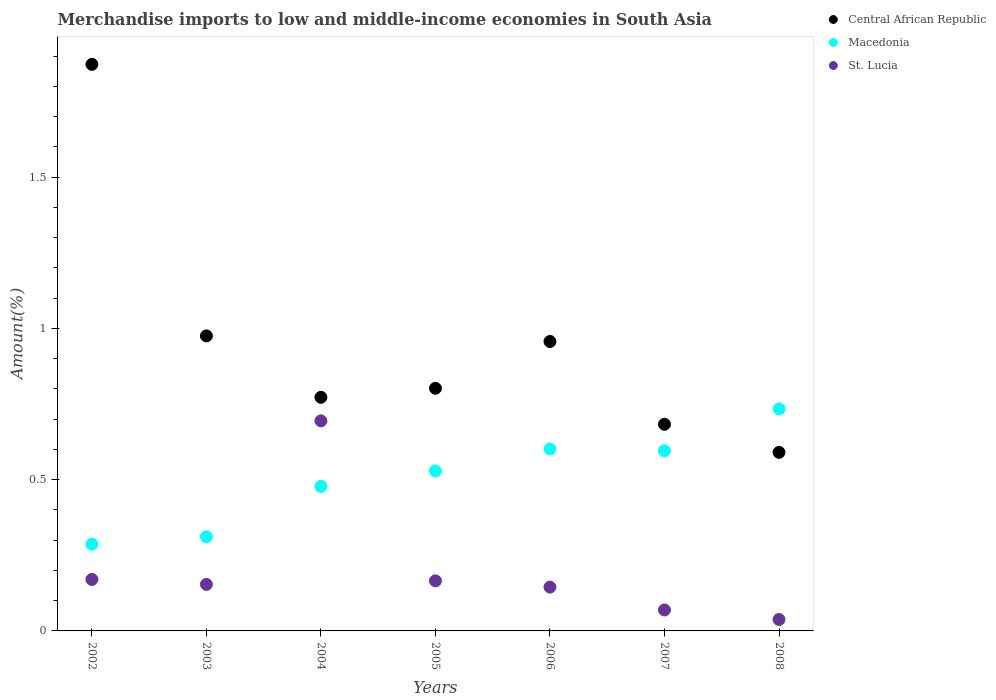Is the number of dotlines equal to the number of legend labels?
Provide a short and direct response. Yes. What is the percentage of amount earned from merchandise imports in St. Lucia in 2007?
Provide a succinct answer. 0.07. Across all years, what is the maximum percentage of amount earned from merchandise imports in St. Lucia?
Give a very brief answer. 0.69. Across all years, what is the minimum percentage of amount earned from merchandise imports in St. Lucia?
Your answer should be compact. 0.04. What is the total percentage of amount earned from merchandise imports in Macedonia in the graph?
Give a very brief answer. 3.54. What is the difference between the percentage of amount earned from merchandise imports in Central African Republic in 2004 and that in 2008?
Your answer should be very brief. 0.18. What is the difference between the percentage of amount earned from merchandise imports in St. Lucia in 2002 and the percentage of amount earned from merchandise imports in Macedonia in 2007?
Keep it short and to the point. -0.43. What is the average percentage of amount earned from merchandise imports in Central African Republic per year?
Make the answer very short. 0.95. In the year 2005, what is the difference between the percentage of amount earned from merchandise imports in St. Lucia and percentage of amount earned from merchandise imports in Central African Republic?
Your answer should be compact. -0.64. In how many years, is the percentage of amount earned from merchandise imports in Macedonia greater than 1.1 %?
Give a very brief answer. 0. What is the ratio of the percentage of amount earned from merchandise imports in Macedonia in 2004 to that in 2007?
Offer a very short reply. 0.8. Is the difference between the percentage of amount earned from merchandise imports in St. Lucia in 2007 and 2008 greater than the difference between the percentage of amount earned from merchandise imports in Central African Republic in 2007 and 2008?
Your response must be concise. No. What is the difference between the highest and the second highest percentage of amount earned from merchandise imports in Central African Republic?
Provide a succinct answer. 0.9. What is the difference between the highest and the lowest percentage of amount earned from merchandise imports in St. Lucia?
Your answer should be compact. 0.66. Does the percentage of amount earned from merchandise imports in St. Lucia monotonically increase over the years?
Your answer should be very brief. No. Is the percentage of amount earned from merchandise imports in Central African Republic strictly greater than the percentage of amount earned from merchandise imports in St. Lucia over the years?
Offer a terse response. Yes. What is the difference between two consecutive major ticks on the Y-axis?
Ensure brevity in your answer.  0.5. Does the graph contain any zero values?
Keep it short and to the point. No. Does the graph contain grids?
Make the answer very short. No. What is the title of the graph?
Ensure brevity in your answer.  Merchandise imports to low and middle-income economies in South Asia. Does "Kuwait" appear as one of the legend labels in the graph?
Make the answer very short. No. What is the label or title of the X-axis?
Give a very brief answer. Years. What is the label or title of the Y-axis?
Offer a very short reply. Amount(%). What is the Amount(%) of Central African Republic in 2002?
Offer a terse response. 1.87. What is the Amount(%) of Macedonia in 2002?
Make the answer very short. 0.29. What is the Amount(%) in St. Lucia in 2002?
Offer a very short reply. 0.17. What is the Amount(%) of Central African Republic in 2003?
Keep it short and to the point. 0.98. What is the Amount(%) in Macedonia in 2003?
Give a very brief answer. 0.31. What is the Amount(%) in St. Lucia in 2003?
Ensure brevity in your answer.  0.15. What is the Amount(%) in Central African Republic in 2004?
Your answer should be compact. 0.77. What is the Amount(%) of Macedonia in 2004?
Keep it short and to the point. 0.48. What is the Amount(%) in St. Lucia in 2004?
Provide a short and direct response. 0.69. What is the Amount(%) of Central African Republic in 2005?
Your answer should be very brief. 0.8. What is the Amount(%) in Macedonia in 2005?
Offer a terse response. 0.53. What is the Amount(%) in St. Lucia in 2005?
Ensure brevity in your answer.  0.17. What is the Amount(%) in Central African Republic in 2006?
Give a very brief answer. 0.96. What is the Amount(%) of Macedonia in 2006?
Give a very brief answer. 0.6. What is the Amount(%) of St. Lucia in 2006?
Give a very brief answer. 0.14. What is the Amount(%) in Central African Republic in 2007?
Ensure brevity in your answer.  0.68. What is the Amount(%) of Macedonia in 2007?
Provide a succinct answer. 0.6. What is the Amount(%) in St. Lucia in 2007?
Offer a terse response. 0.07. What is the Amount(%) of Central African Republic in 2008?
Provide a succinct answer. 0.59. What is the Amount(%) of Macedonia in 2008?
Provide a short and direct response. 0.73. What is the Amount(%) in St. Lucia in 2008?
Make the answer very short. 0.04. Across all years, what is the maximum Amount(%) in Central African Republic?
Keep it short and to the point. 1.87. Across all years, what is the maximum Amount(%) in Macedonia?
Offer a terse response. 0.73. Across all years, what is the maximum Amount(%) in St. Lucia?
Provide a short and direct response. 0.69. Across all years, what is the minimum Amount(%) in Central African Republic?
Provide a succinct answer. 0.59. Across all years, what is the minimum Amount(%) in Macedonia?
Give a very brief answer. 0.29. Across all years, what is the minimum Amount(%) of St. Lucia?
Give a very brief answer. 0.04. What is the total Amount(%) of Central African Republic in the graph?
Ensure brevity in your answer.  6.65. What is the total Amount(%) of Macedonia in the graph?
Your answer should be very brief. 3.54. What is the total Amount(%) of St. Lucia in the graph?
Offer a very short reply. 1.44. What is the difference between the Amount(%) in Central African Republic in 2002 and that in 2003?
Keep it short and to the point. 0.9. What is the difference between the Amount(%) of Macedonia in 2002 and that in 2003?
Ensure brevity in your answer.  -0.02. What is the difference between the Amount(%) of St. Lucia in 2002 and that in 2003?
Your answer should be compact. 0.02. What is the difference between the Amount(%) of Central African Republic in 2002 and that in 2004?
Your answer should be very brief. 1.1. What is the difference between the Amount(%) in Macedonia in 2002 and that in 2004?
Give a very brief answer. -0.19. What is the difference between the Amount(%) in St. Lucia in 2002 and that in 2004?
Your answer should be very brief. -0.52. What is the difference between the Amount(%) of Central African Republic in 2002 and that in 2005?
Make the answer very short. 1.07. What is the difference between the Amount(%) of Macedonia in 2002 and that in 2005?
Ensure brevity in your answer.  -0.24. What is the difference between the Amount(%) in St. Lucia in 2002 and that in 2005?
Give a very brief answer. 0. What is the difference between the Amount(%) in Central African Republic in 2002 and that in 2006?
Provide a succinct answer. 0.92. What is the difference between the Amount(%) of Macedonia in 2002 and that in 2006?
Make the answer very short. -0.31. What is the difference between the Amount(%) of St. Lucia in 2002 and that in 2006?
Your response must be concise. 0.03. What is the difference between the Amount(%) of Central African Republic in 2002 and that in 2007?
Your answer should be compact. 1.19. What is the difference between the Amount(%) of Macedonia in 2002 and that in 2007?
Give a very brief answer. -0.31. What is the difference between the Amount(%) of St. Lucia in 2002 and that in 2007?
Keep it short and to the point. 0.1. What is the difference between the Amount(%) of Central African Republic in 2002 and that in 2008?
Provide a short and direct response. 1.28. What is the difference between the Amount(%) of Macedonia in 2002 and that in 2008?
Your answer should be compact. -0.45. What is the difference between the Amount(%) in St. Lucia in 2002 and that in 2008?
Your answer should be very brief. 0.13. What is the difference between the Amount(%) of Central African Republic in 2003 and that in 2004?
Keep it short and to the point. 0.2. What is the difference between the Amount(%) in Macedonia in 2003 and that in 2004?
Provide a succinct answer. -0.17. What is the difference between the Amount(%) of St. Lucia in 2003 and that in 2004?
Keep it short and to the point. -0.54. What is the difference between the Amount(%) in Central African Republic in 2003 and that in 2005?
Your answer should be very brief. 0.17. What is the difference between the Amount(%) of Macedonia in 2003 and that in 2005?
Provide a succinct answer. -0.22. What is the difference between the Amount(%) in St. Lucia in 2003 and that in 2005?
Make the answer very short. -0.01. What is the difference between the Amount(%) of Central African Republic in 2003 and that in 2006?
Give a very brief answer. 0.02. What is the difference between the Amount(%) in Macedonia in 2003 and that in 2006?
Offer a terse response. -0.29. What is the difference between the Amount(%) in St. Lucia in 2003 and that in 2006?
Your answer should be very brief. 0.01. What is the difference between the Amount(%) of Central African Republic in 2003 and that in 2007?
Your answer should be compact. 0.29. What is the difference between the Amount(%) in Macedonia in 2003 and that in 2007?
Keep it short and to the point. -0.28. What is the difference between the Amount(%) of St. Lucia in 2003 and that in 2007?
Offer a terse response. 0.08. What is the difference between the Amount(%) of Central African Republic in 2003 and that in 2008?
Provide a short and direct response. 0.39. What is the difference between the Amount(%) in Macedonia in 2003 and that in 2008?
Keep it short and to the point. -0.42. What is the difference between the Amount(%) of St. Lucia in 2003 and that in 2008?
Provide a short and direct response. 0.12. What is the difference between the Amount(%) of Central African Republic in 2004 and that in 2005?
Keep it short and to the point. -0.03. What is the difference between the Amount(%) of Macedonia in 2004 and that in 2005?
Offer a very short reply. -0.05. What is the difference between the Amount(%) of St. Lucia in 2004 and that in 2005?
Offer a terse response. 0.53. What is the difference between the Amount(%) in Central African Republic in 2004 and that in 2006?
Your answer should be very brief. -0.18. What is the difference between the Amount(%) in Macedonia in 2004 and that in 2006?
Your response must be concise. -0.12. What is the difference between the Amount(%) in St. Lucia in 2004 and that in 2006?
Keep it short and to the point. 0.55. What is the difference between the Amount(%) of Central African Republic in 2004 and that in 2007?
Give a very brief answer. 0.09. What is the difference between the Amount(%) of Macedonia in 2004 and that in 2007?
Offer a terse response. -0.12. What is the difference between the Amount(%) of St. Lucia in 2004 and that in 2007?
Your response must be concise. 0.63. What is the difference between the Amount(%) of Central African Republic in 2004 and that in 2008?
Provide a short and direct response. 0.18. What is the difference between the Amount(%) of Macedonia in 2004 and that in 2008?
Offer a very short reply. -0.26. What is the difference between the Amount(%) in St. Lucia in 2004 and that in 2008?
Your answer should be very brief. 0.66. What is the difference between the Amount(%) in Central African Republic in 2005 and that in 2006?
Provide a succinct answer. -0.15. What is the difference between the Amount(%) in Macedonia in 2005 and that in 2006?
Your answer should be very brief. -0.07. What is the difference between the Amount(%) in St. Lucia in 2005 and that in 2006?
Your response must be concise. 0.02. What is the difference between the Amount(%) in Central African Republic in 2005 and that in 2007?
Make the answer very short. 0.12. What is the difference between the Amount(%) of Macedonia in 2005 and that in 2007?
Make the answer very short. -0.07. What is the difference between the Amount(%) of St. Lucia in 2005 and that in 2007?
Provide a short and direct response. 0.1. What is the difference between the Amount(%) of Central African Republic in 2005 and that in 2008?
Offer a terse response. 0.21. What is the difference between the Amount(%) in Macedonia in 2005 and that in 2008?
Your answer should be compact. -0.21. What is the difference between the Amount(%) of St. Lucia in 2005 and that in 2008?
Ensure brevity in your answer.  0.13. What is the difference between the Amount(%) of Central African Republic in 2006 and that in 2007?
Give a very brief answer. 0.27. What is the difference between the Amount(%) in Macedonia in 2006 and that in 2007?
Keep it short and to the point. 0.01. What is the difference between the Amount(%) in St. Lucia in 2006 and that in 2007?
Give a very brief answer. 0.08. What is the difference between the Amount(%) of Central African Republic in 2006 and that in 2008?
Keep it short and to the point. 0.37. What is the difference between the Amount(%) in Macedonia in 2006 and that in 2008?
Provide a succinct answer. -0.13. What is the difference between the Amount(%) of St. Lucia in 2006 and that in 2008?
Your answer should be very brief. 0.11. What is the difference between the Amount(%) of Central African Republic in 2007 and that in 2008?
Offer a very short reply. 0.09. What is the difference between the Amount(%) in Macedonia in 2007 and that in 2008?
Make the answer very short. -0.14. What is the difference between the Amount(%) of St. Lucia in 2007 and that in 2008?
Give a very brief answer. 0.03. What is the difference between the Amount(%) of Central African Republic in 2002 and the Amount(%) of Macedonia in 2003?
Ensure brevity in your answer.  1.56. What is the difference between the Amount(%) of Central African Republic in 2002 and the Amount(%) of St. Lucia in 2003?
Offer a very short reply. 1.72. What is the difference between the Amount(%) of Macedonia in 2002 and the Amount(%) of St. Lucia in 2003?
Your response must be concise. 0.13. What is the difference between the Amount(%) of Central African Republic in 2002 and the Amount(%) of Macedonia in 2004?
Ensure brevity in your answer.  1.4. What is the difference between the Amount(%) in Central African Republic in 2002 and the Amount(%) in St. Lucia in 2004?
Offer a very short reply. 1.18. What is the difference between the Amount(%) in Macedonia in 2002 and the Amount(%) in St. Lucia in 2004?
Provide a short and direct response. -0.41. What is the difference between the Amount(%) of Central African Republic in 2002 and the Amount(%) of Macedonia in 2005?
Offer a terse response. 1.34. What is the difference between the Amount(%) of Central African Republic in 2002 and the Amount(%) of St. Lucia in 2005?
Offer a very short reply. 1.71. What is the difference between the Amount(%) of Macedonia in 2002 and the Amount(%) of St. Lucia in 2005?
Offer a terse response. 0.12. What is the difference between the Amount(%) of Central African Republic in 2002 and the Amount(%) of Macedonia in 2006?
Provide a succinct answer. 1.27. What is the difference between the Amount(%) in Central African Republic in 2002 and the Amount(%) in St. Lucia in 2006?
Your answer should be very brief. 1.73. What is the difference between the Amount(%) in Macedonia in 2002 and the Amount(%) in St. Lucia in 2006?
Provide a short and direct response. 0.14. What is the difference between the Amount(%) in Central African Republic in 2002 and the Amount(%) in Macedonia in 2007?
Offer a very short reply. 1.28. What is the difference between the Amount(%) of Central African Republic in 2002 and the Amount(%) of St. Lucia in 2007?
Provide a succinct answer. 1.8. What is the difference between the Amount(%) in Macedonia in 2002 and the Amount(%) in St. Lucia in 2007?
Give a very brief answer. 0.22. What is the difference between the Amount(%) in Central African Republic in 2002 and the Amount(%) in Macedonia in 2008?
Offer a very short reply. 1.14. What is the difference between the Amount(%) of Central African Republic in 2002 and the Amount(%) of St. Lucia in 2008?
Ensure brevity in your answer.  1.84. What is the difference between the Amount(%) in Macedonia in 2002 and the Amount(%) in St. Lucia in 2008?
Give a very brief answer. 0.25. What is the difference between the Amount(%) of Central African Republic in 2003 and the Amount(%) of Macedonia in 2004?
Your answer should be compact. 0.5. What is the difference between the Amount(%) of Central African Republic in 2003 and the Amount(%) of St. Lucia in 2004?
Keep it short and to the point. 0.28. What is the difference between the Amount(%) in Macedonia in 2003 and the Amount(%) in St. Lucia in 2004?
Keep it short and to the point. -0.38. What is the difference between the Amount(%) in Central African Republic in 2003 and the Amount(%) in Macedonia in 2005?
Provide a short and direct response. 0.45. What is the difference between the Amount(%) in Central African Republic in 2003 and the Amount(%) in St. Lucia in 2005?
Make the answer very short. 0.81. What is the difference between the Amount(%) in Macedonia in 2003 and the Amount(%) in St. Lucia in 2005?
Provide a succinct answer. 0.15. What is the difference between the Amount(%) of Central African Republic in 2003 and the Amount(%) of Macedonia in 2006?
Give a very brief answer. 0.37. What is the difference between the Amount(%) of Central African Republic in 2003 and the Amount(%) of St. Lucia in 2006?
Make the answer very short. 0.83. What is the difference between the Amount(%) in Macedonia in 2003 and the Amount(%) in St. Lucia in 2006?
Your response must be concise. 0.17. What is the difference between the Amount(%) in Central African Republic in 2003 and the Amount(%) in Macedonia in 2007?
Provide a succinct answer. 0.38. What is the difference between the Amount(%) in Central African Republic in 2003 and the Amount(%) in St. Lucia in 2007?
Your response must be concise. 0.91. What is the difference between the Amount(%) of Macedonia in 2003 and the Amount(%) of St. Lucia in 2007?
Offer a terse response. 0.24. What is the difference between the Amount(%) of Central African Republic in 2003 and the Amount(%) of Macedonia in 2008?
Make the answer very short. 0.24. What is the difference between the Amount(%) of Central African Republic in 2003 and the Amount(%) of St. Lucia in 2008?
Offer a very short reply. 0.94. What is the difference between the Amount(%) in Macedonia in 2003 and the Amount(%) in St. Lucia in 2008?
Give a very brief answer. 0.27. What is the difference between the Amount(%) of Central African Republic in 2004 and the Amount(%) of Macedonia in 2005?
Provide a succinct answer. 0.24. What is the difference between the Amount(%) in Central African Republic in 2004 and the Amount(%) in St. Lucia in 2005?
Your answer should be very brief. 0.61. What is the difference between the Amount(%) of Macedonia in 2004 and the Amount(%) of St. Lucia in 2005?
Your answer should be very brief. 0.31. What is the difference between the Amount(%) in Central African Republic in 2004 and the Amount(%) in Macedonia in 2006?
Ensure brevity in your answer.  0.17. What is the difference between the Amount(%) of Central African Republic in 2004 and the Amount(%) of St. Lucia in 2006?
Give a very brief answer. 0.63. What is the difference between the Amount(%) in Macedonia in 2004 and the Amount(%) in St. Lucia in 2006?
Provide a succinct answer. 0.33. What is the difference between the Amount(%) of Central African Republic in 2004 and the Amount(%) of Macedonia in 2007?
Make the answer very short. 0.18. What is the difference between the Amount(%) of Central African Republic in 2004 and the Amount(%) of St. Lucia in 2007?
Your answer should be compact. 0.7. What is the difference between the Amount(%) of Macedonia in 2004 and the Amount(%) of St. Lucia in 2007?
Make the answer very short. 0.41. What is the difference between the Amount(%) in Central African Republic in 2004 and the Amount(%) in Macedonia in 2008?
Keep it short and to the point. 0.04. What is the difference between the Amount(%) in Central African Republic in 2004 and the Amount(%) in St. Lucia in 2008?
Give a very brief answer. 0.73. What is the difference between the Amount(%) in Macedonia in 2004 and the Amount(%) in St. Lucia in 2008?
Your answer should be compact. 0.44. What is the difference between the Amount(%) in Central African Republic in 2005 and the Amount(%) in Macedonia in 2006?
Your response must be concise. 0.2. What is the difference between the Amount(%) of Central African Republic in 2005 and the Amount(%) of St. Lucia in 2006?
Give a very brief answer. 0.66. What is the difference between the Amount(%) in Macedonia in 2005 and the Amount(%) in St. Lucia in 2006?
Ensure brevity in your answer.  0.38. What is the difference between the Amount(%) of Central African Republic in 2005 and the Amount(%) of Macedonia in 2007?
Your response must be concise. 0.21. What is the difference between the Amount(%) of Central African Republic in 2005 and the Amount(%) of St. Lucia in 2007?
Ensure brevity in your answer.  0.73. What is the difference between the Amount(%) in Macedonia in 2005 and the Amount(%) in St. Lucia in 2007?
Give a very brief answer. 0.46. What is the difference between the Amount(%) in Central African Republic in 2005 and the Amount(%) in Macedonia in 2008?
Keep it short and to the point. 0.07. What is the difference between the Amount(%) in Central African Republic in 2005 and the Amount(%) in St. Lucia in 2008?
Give a very brief answer. 0.76. What is the difference between the Amount(%) of Macedonia in 2005 and the Amount(%) of St. Lucia in 2008?
Give a very brief answer. 0.49. What is the difference between the Amount(%) in Central African Republic in 2006 and the Amount(%) in Macedonia in 2007?
Offer a very short reply. 0.36. What is the difference between the Amount(%) of Central African Republic in 2006 and the Amount(%) of St. Lucia in 2007?
Offer a very short reply. 0.89. What is the difference between the Amount(%) of Macedonia in 2006 and the Amount(%) of St. Lucia in 2007?
Your answer should be very brief. 0.53. What is the difference between the Amount(%) of Central African Republic in 2006 and the Amount(%) of Macedonia in 2008?
Make the answer very short. 0.22. What is the difference between the Amount(%) in Central African Republic in 2006 and the Amount(%) in St. Lucia in 2008?
Make the answer very short. 0.92. What is the difference between the Amount(%) in Macedonia in 2006 and the Amount(%) in St. Lucia in 2008?
Provide a short and direct response. 0.56. What is the difference between the Amount(%) of Central African Republic in 2007 and the Amount(%) of Macedonia in 2008?
Offer a terse response. -0.05. What is the difference between the Amount(%) of Central African Republic in 2007 and the Amount(%) of St. Lucia in 2008?
Make the answer very short. 0.65. What is the difference between the Amount(%) of Macedonia in 2007 and the Amount(%) of St. Lucia in 2008?
Offer a terse response. 0.56. What is the average Amount(%) in Central African Republic per year?
Offer a terse response. 0.95. What is the average Amount(%) of Macedonia per year?
Offer a very short reply. 0.51. What is the average Amount(%) of St. Lucia per year?
Provide a succinct answer. 0.21. In the year 2002, what is the difference between the Amount(%) in Central African Republic and Amount(%) in Macedonia?
Your response must be concise. 1.59. In the year 2002, what is the difference between the Amount(%) of Central African Republic and Amount(%) of St. Lucia?
Your answer should be compact. 1.7. In the year 2002, what is the difference between the Amount(%) in Macedonia and Amount(%) in St. Lucia?
Make the answer very short. 0.12. In the year 2003, what is the difference between the Amount(%) of Central African Republic and Amount(%) of Macedonia?
Give a very brief answer. 0.66. In the year 2003, what is the difference between the Amount(%) in Central African Republic and Amount(%) in St. Lucia?
Provide a succinct answer. 0.82. In the year 2003, what is the difference between the Amount(%) of Macedonia and Amount(%) of St. Lucia?
Offer a very short reply. 0.16. In the year 2004, what is the difference between the Amount(%) of Central African Republic and Amount(%) of Macedonia?
Ensure brevity in your answer.  0.29. In the year 2004, what is the difference between the Amount(%) in Central African Republic and Amount(%) in St. Lucia?
Give a very brief answer. 0.08. In the year 2004, what is the difference between the Amount(%) in Macedonia and Amount(%) in St. Lucia?
Provide a succinct answer. -0.22. In the year 2005, what is the difference between the Amount(%) in Central African Republic and Amount(%) in Macedonia?
Provide a succinct answer. 0.27. In the year 2005, what is the difference between the Amount(%) in Central African Republic and Amount(%) in St. Lucia?
Give a very brief answer. 0.64. In the year 2005, what is the difference between the Amount(%) of Macedonia and Amount(%) of St. Lucia?
Your answer should be very brief. 0.36. In the year 2006, what is the difference between the Amount(%) of Central African Republic and Amount(%) of Macedonia?
Provide a short and direct response. 0.36. In the year 2006, what is the difference between the Amount(%) of Central African Republic and Amount(%) of St. Lucia?
Keep it short and to the point. 0.81. In the year 2006, what is the difference between the Amount(%) in Macedonia and Amount(%) in St. Lucia?
Make the answer very short. 0.46. In the year 2007, what is the difference between the Amount(%) of Central African Republic and Amount(%) of Macedonia?
Ensure brevity in your answer.  0.09. In the year 2007, what is the difference between the Amount(%) of Central African Republic and Amount(%) of St. Lucia?
Provide a short and direct response. 0.61. In the year 2007, what is the difference between the Amount(%) of Macedonia and Amount(%) of St. Lucia?
Make the answer very short. 0.53. In the year 2008, what is the difference between the Amount(%) in Central African Republic and Amount(%) in Macedonia?
Keep it short and to the point. -0.14. In the year 2008, what is the difference between the Amount(%) of Central African Republic and Amount(%) of St. Lucia?
Your answer should be compact. 0.55. In the year 2008, what is the difference between the Amount(%) of Macedonia and Amount(%) of St. Lucia?
Keep it short and to the point. 0.7. What is the ratio of the Amount(%) in Central African Republic in 2002 to that in 2003?
Give a very brief answer. 1.92. What is the ratio of the Amount(%) in Macedonia in 2002 to that in 2003?
Provide a short and direct response. 0.92. What is the ratio of the Amount(%) of St. Lucia in 2002 to that in 2003?
Keep it short and to the point. 1.11. What is the ratio of the Amount(%) of Central African Republic in 2002 to that in 2004?
Your answer should be very brief. 2.43. What is the ratio of the Amount(%) in Macedonia in 2002 to that in 2004?
Ensure brevity in your answer.  0.6. What is the ratio of the Amount(%) in St. Lucia in 2002 to that in 2004?
Provide a short and direct response. 0.25. What is the ratio of the Amount(%) of Central African Republic in 2002 to that in 2005?
Ensure brevity in your answer.  2.34. What is the ratio of the Amount(%) in Macedonia in 2002 to that in 2005?
Ensure brevity in your answer.  0.54. What is the ratio of the Amount(%) of St. Lucia in 2002 to that in 2005?
Give a very brief answer. 1.03. What is the ratio of the Amount(%) of Central African Republic in 2002 to that in 2006?
Give a very brief answer. 1.96. What is the ratio of the Amount(%) of Macedonia in 2002 to that in 2006?
Ensure brevity in your answer.  0.48. What is the ratio of the Amount(%) of St. Lucia in 2002 to that in 2006?
Provide a short and direct response. 1.18. What is the ratio of the Amount(%) of Central African Republic in 2002 to that in 2007?
Your answer should be very brief. 2.74. What is the ratio of the Amount(%) in Macedonia in 2002 to that in 2007?
Offer a terse response. 0.48. What is the ratio of the Amount(%) in St. Lucia in 2002 to that in 2007?
Offer a very short reply. 2.45. What is the ratio of the Amount(%) in Central African Republic in 2002 to that in 2008?
Provide a short and direct response. 3.17. What is the ratio of the Amount(%) of Macedonia in 2002 to that in 2008?
Ensure brevity in your answer.  0.39. What is the ratio of the Amount(%) of St. Lucia in 2002 to that in 2008?
Keep it short and to the point. 4.5. What is the ratio of the Amount(%) in Central African Republic in 2003 to that in 2004?
Offer a terse response. 1.26. What is the ratio of the Amount(%) of Macedonia in 2003 to that in 2004?
Offer a very short reply. 0.65. What is the ratio of the Amount(%) of St. Lucia in 2003 to that in 2004?
Give a very brief answer. 0.22. What is the ratio of the Amount(%) in Central African Republic in 2003 to that in 2005?
Make the answer very short. 1.22. What is the ratio of the Amount(%) of Macedonia in 2003 to that in 2005?
Your answer should be compact. 0.59. What is the ratio of the Amount(%) of St. Lucia in 2003 to that in 2005?
Give a very brief answer. 0.93. What is the ratio of the Amount(%) in Central African Republic in 2003 to that in 2006?
Keep it short and to the point. 1.02. What is the ratio of the Amount(%) in Macedonia in 2003 to that in 2006?
Your response must be concise. 0.52. What is the ratio of the Amount(%) of St. Lucia in 2003 to that in 2006?
Ensure brevity in your answer.  1.06. What is the ratio of the Amount(%) in Central African Republic in 2003 to that in 2007?
Ensure brevity in your answer.  1.43. What is the ratio of the Amount(%) in Macedonia in 2003 to that in 2007?
Provide a succinct answer. 0.52. What is the ratio of the Amount(%) in St. Lucia in 2003 to that in 2007?
Keep it short and to the point. 2.22. What is the ratio of the Amount(%) in Central African Republic in 2003 to that in 2008?
Your answer should be compact. 1.65. What is the ratio of the Amount(%) in Macedonia in 2003 to that in 2008?
Your response must be concise. 0.42. What is the ratio of the Amount(%) of St. Lucia in 2003 to that in 2008?
Your answer should be compact. 4.07. What is the ratio of the Amount(%) in Central African Republic in 2004 to that in 2005?
Keep it short and to the point. 0.96. What is the ratio of the Amount(%) of Macedonia in 2004 to that in 2005?
Keep it short and to the point. 0.9. What is the ratio of the Amount(%) in St. Lucia in 2004 to that in 2005?
Give a very brief answer. 4.2. What is the ratio of the Amount(%) of Central African Republic in 2004 to that in 2006?
Your response must be concise. 0.81. What is the ratio of the Amount(%) in Macedonia in 2004 to that in 2006?
Keep it short and to the point. 0.79. What is the ratio of the Amount(%) in St. Lucia in 2004 to that in 2006?
Provide a short and direct response. 4.8. What is the ratio of the Amount(%) of Central African Republic in 2004 to that in 2007?
Give a very brief answer. 1.13. What is the ratio of the Amount(%) of Macedonia in 2004 to that in 2007?
Ensure brevity in your answer.  0.8. What is the ratio of the Amount(%) in St. Lucia in 2004 to that in 2007?
Provide a short and direct response. 10.02. What is the ratio of the Amount(%) in Central African Republic in 2004 to that in 2008?
Offer a terse response. 1.31. What is the ratio of the Amount(%) of Macedonia in 2004 to that in 2008?
Your answer should be compact. 0.65. What is the ratio of the Amount(%) in St. Lucia in 2004 to that in 2008?
Give a very brief answer. 18.38. What is the ratio of the Amount(%) of Central African Republic in 2005 to that in 2006?
Provide a short and direct response. 0.84. What is the ratio of the Amount(%) of Macedonia in 2005 to that in 2006?
Give a very brief answer. 0.88. What is the ratio of the Amount(%) of St. Lucia in 2005 to that in 2006?
Your answer should be very brief. 1.14. What is the ratio of the Amount(%) of Central African Republic in 2005 to that in 2007?
Make the answer very short. 1.17. What is the ratio of the Amount(%) in Macedonia in 2005 to that in 2007?
Your answer should be very brief. 0.89. What is the ratio of the Amount(%) in St. Lucia in 2005 to that in 2007?
Your answer should be very brief. 2.39. What is the ratio of the Amount(%) of Central African Republic in 2005 to that in 2008?
Keep it short and to the point. 1.36. What is the ratio of the Amount(%) of Macedonia in 2005 to that in 2008?
Your answer should be very brief. 0.72. What is the ratio of the Amount(%) of St. Lucia in 2005 to that in 2008?
Offer a very short reply. 4.38. What is the ratio of the Amount(%) in Central African Republic in 2006 to that in 2007?
Your answer should be compact. 1.4. What is the ratio of the Amount(%) in Macedonia in 2006 to that in 2007?
Provide a short and direct response. 1.01. What is the ratio of the Amount(%) in St. Lucia in 2006 to that in 2007?
Offer a very short reply. 2.09. What is the ratio of the Amount(%) in Central African Republic in 2006 to that in 2008?
Offer a terse response. 1.62. What is the ratio of the Amount(%) in Macedonia in 2006 to that in 2008?
Provide a short and direct response. 0.82. What is the ratio of the Amount(%) of St. Lucia in 2006 to that in 2008?
Give a very brief answer. 3.83. What is the ratio of the Amount(%) in Central African Republic in 2007 to that in 2008?
Your answer should be very brief. 1.16. What is the ratio of the Amount(%) in Macedonia in 2007 to that in 2008?
Offer a very short reply. 0.81. What is the ratio of the Amount(%) of St. Lucia in 2007 to that in 2008?
Give a very brief answer. 1.84. What is the difference between the highest and the second highest Amount(%) of Central African Republic?
Offer a very short reply. 0.9. What is the difference between the highest and the second highest Amount(%) of Macedonia?
Make the answer very short. 0.13. What is the difference between the highest and the second highest Amount(%) in St. Lucia?
Offer a very short reply. 0.52. What is the difference between the highest and the lowest Amount(%) of Central African Republic?
Give a very brief answer. 1.28. What is the difference between the highest and the lowest Amount(%) in Macedonia?
Ensure brevity in your answer.  0.45. What is the difference between the highest and the lowest Amount(%) in St. Lucia?
Your response must be concise. 0.66. 